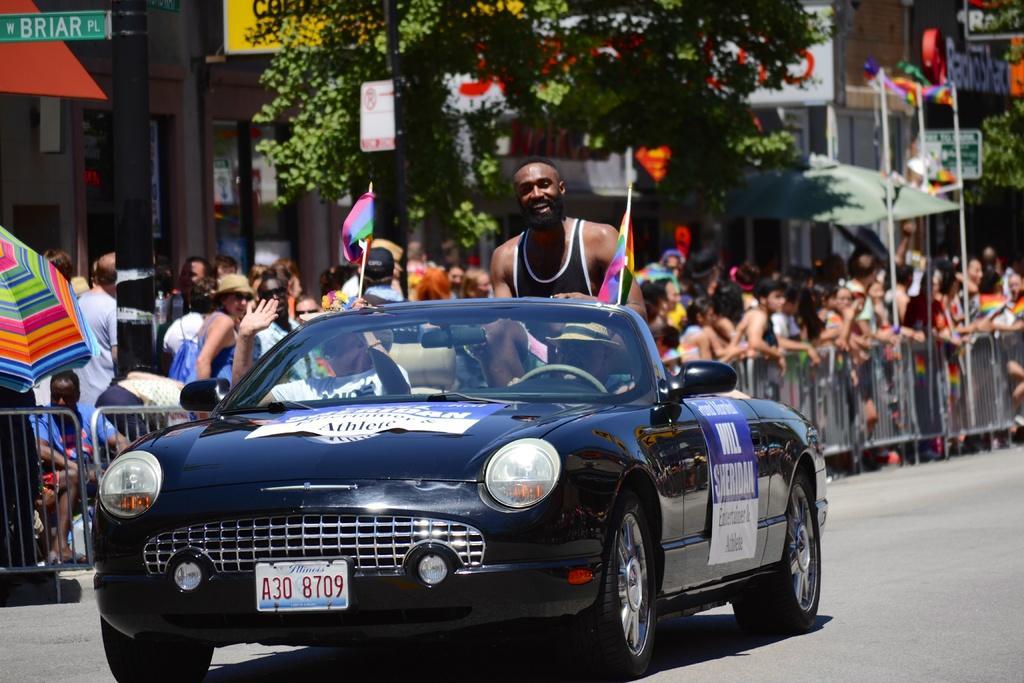How would you summarize this image in a sentence or two? In this picture we can see a few people in the car. There are few flags and a poster on this car. There are some barricades from left to right. Few people are visible at the back. We can see a sign board. Few trees are visible in the background. 